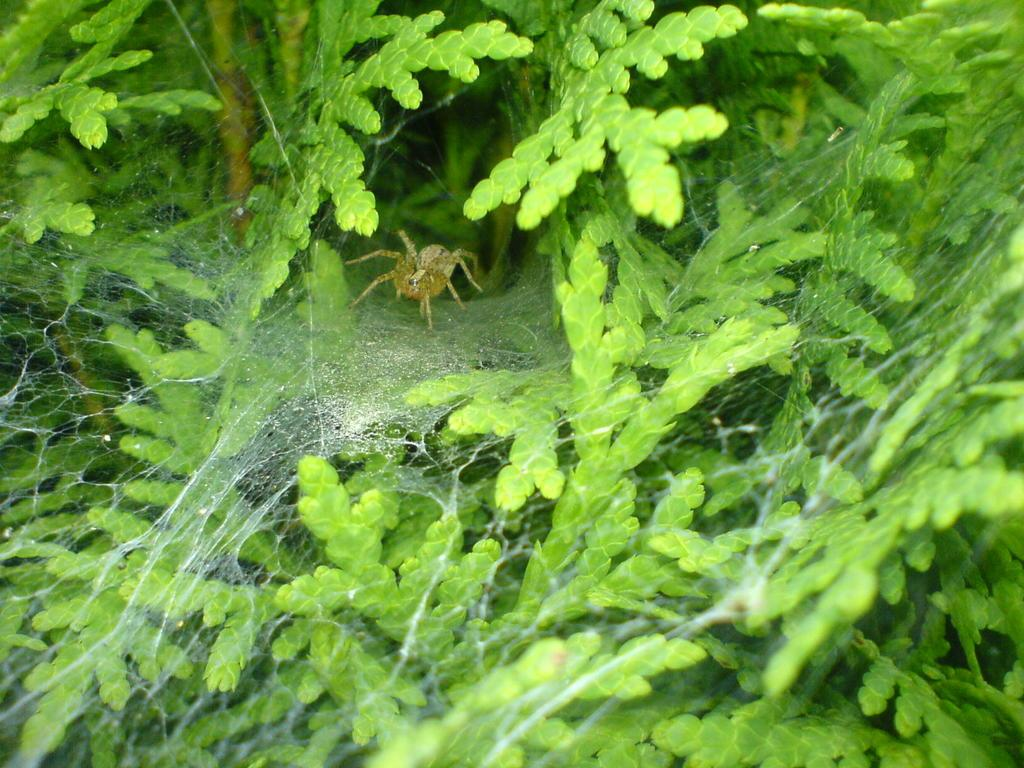What is the main subject of the picture? The main subject of the picture is a tree. Are there any additional features on the tree? Yes, there is a spider web on the leaves of the tree. What can be found within the spider web? A spider is present in the spider web. What type of oven can be seen in the picture? There is no oven present in the picture; it features a tree with a spider web and a spider. Can you tell me how many sails are attached to the tree in the picture? There are no sails present in the picture; it features a tree with a spider web and a spider. 